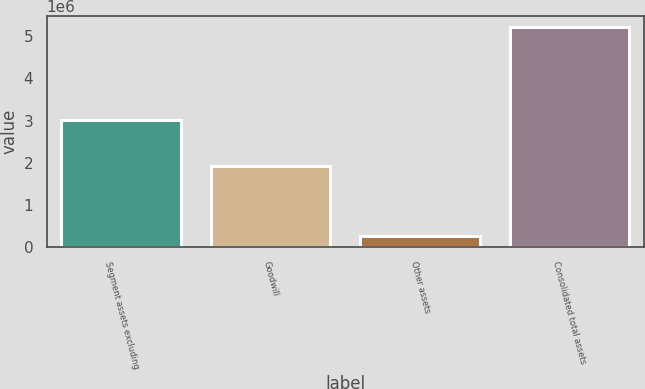Convert chart to OTSL. <chart><loc_0><loc_0><loc_500><loc_500><bar_chart><fcel>Segment assets excluding<fcel>Goodwill<fcel>Other assets<fcel>Consolidated total assets<nl><fcel>3.00512e+06<fcel>1.93274e+06<fcel>277601<fcel>5.21546e+06<nl></chart> 